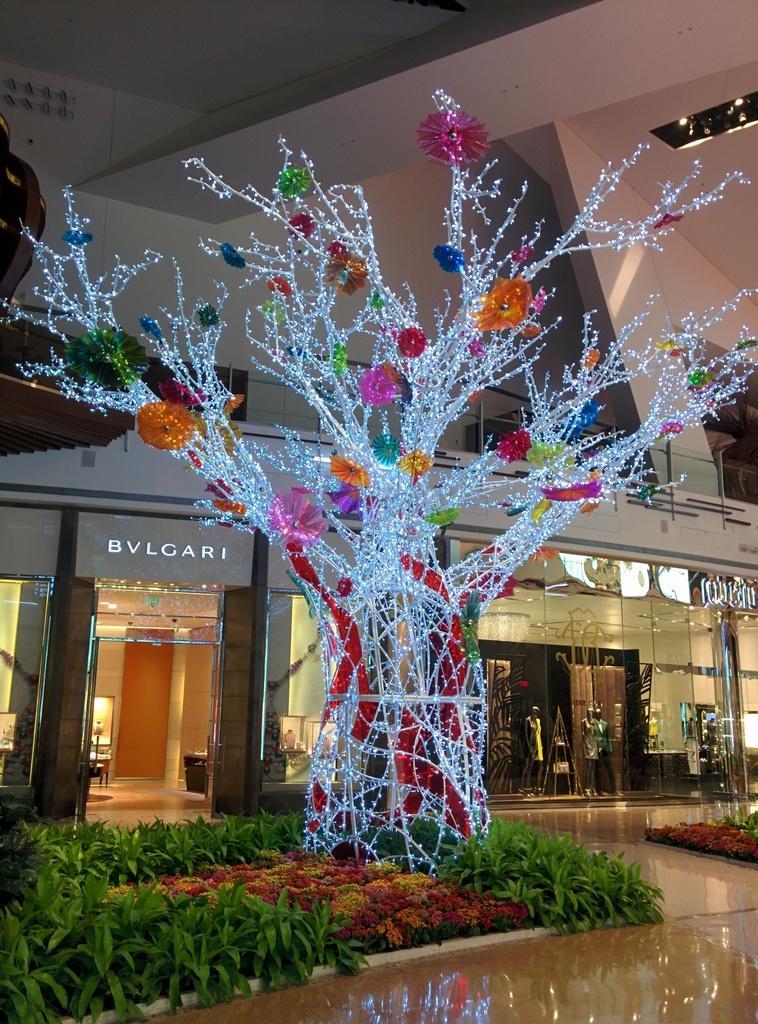Describe this image in one or two sentences. In the picture we can see lights which are decorated in the shape of tree, there are some plants, flowers and in the background there is glass door and top of the picture there is roof. 